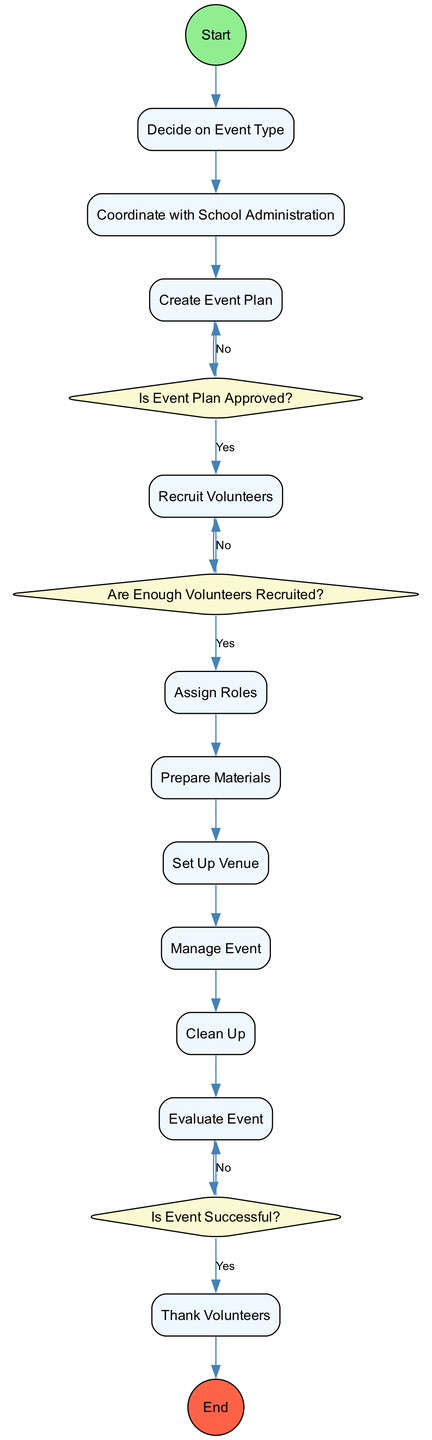What is the first activity in the diagram? The diagram starts with "Decide on Event Type," which is specified as the first activity in the transitions.
Answer: Decide on Event Type How many decisions are present in the diagram? There are three decisions listed: "Is Event Plan Approved?", "Are Enough Volunteers Recruited?", and "Is Event Successful?". Counting these gives a total of three decisions.
Answer: 3 What happens if the event plan is not approved? If the event plan is not approved, the process returns to "Create Event Plan," as indicated by the transition path labeled "No" from the decision node.
Answer: Create Event Plan What activity follows "Clean Up"? After "Clean Up," the next activity according to the diagram is "Evaluate Event." This is confirmed by the direct transition from "Clean Up" to "Evaluate Event."
Answer: Evaluate Event What must occur before recruiting volunteers? Before recruiting volunteers, the event plan must be approved. This is a prerequisite as indicated by the decision "Is Event Plan Approved?" that must have a "Yes" response to proceed to "Recruit Volunteers."
Answer: Event Plan Approved What is the last activity in the diagram? The final activity outlined in the diagram is "Thank Volunteers," which comes before the end node, indicating the conclusion of the process.
Answer: Thank Volunteers If there are not enough volunteers, what is the next step? If there are not enough volunteers, the process goes back to "Recruit Volunteers," as shown by the "No" path from the decision "Are Enough Volunteers Recruited?"
Answer: Recruit Volunteers Is there a direct transition from "Manage Event" to "Thank Volunteers"? No, there is no direct transition from "Manage Event" to "Thank Volunteers." The flow goes through "Clean Up" and "Evaluate Event" before reaching "Thank Volunteers."
Answer: No 